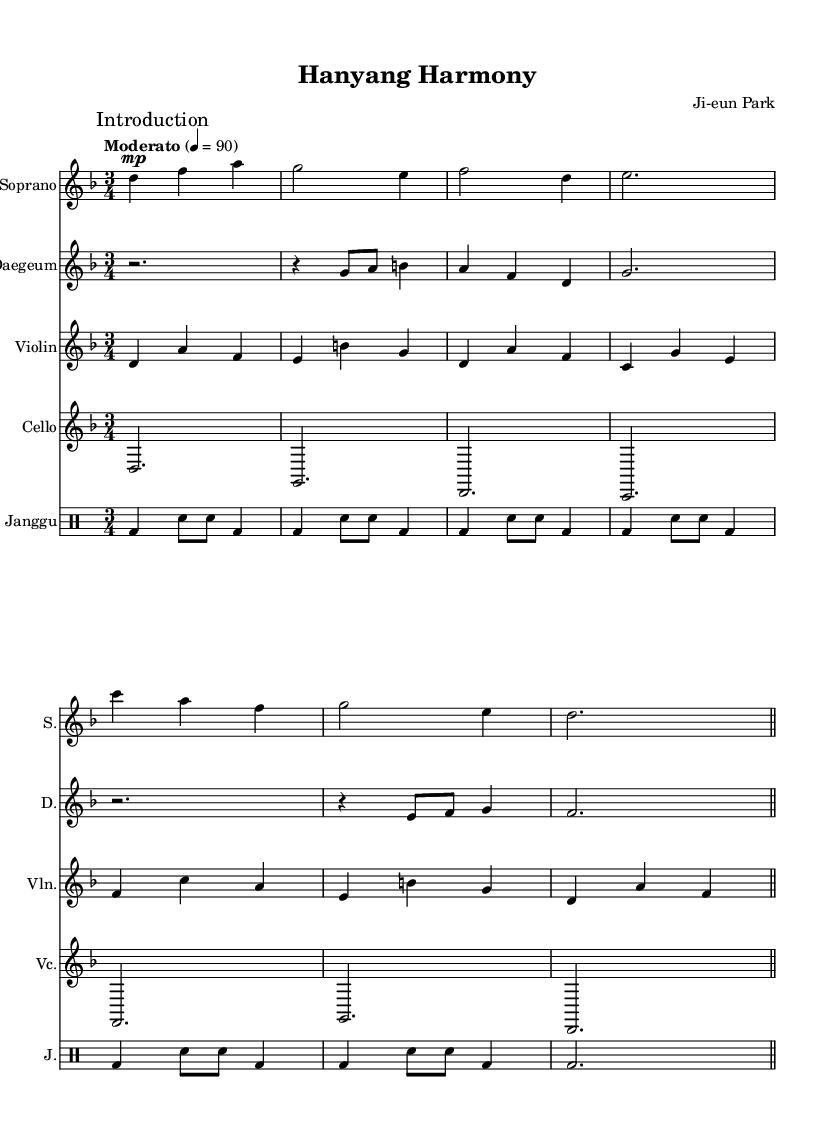What is the key signature of this music? The key signature is D minor, which includes one flat (B flat). We can identify the key signature indicated at the beginning of the staff, which specifies that this piece is in D minor.
Answer: D minor What is the time signature of this music? The time signature is 3/4, which means there are three beats in each measure and the quarter note gets one beat. This is noted in the time signature at the beginning of the score.
Answer: 3/4 What is the tempo marking of this piece? The tempo marking is Moderato, indicated at the beginning of the score with a metronome marking of 90 beats per minute. This informs the performers to play at a moderate speed.
Answer: Moderato Which instrument plays the introduction? The introduction is played by the Soprano, as indicated by the mark in the score and the first section notated under the Soprano staff.
Answer: Soprano How many measures are there in the excerpt? There are a total of 8 measures in the excerpt, as we can count the vertical bar lines that separate the measures across the staves.
Answer: 8 What instrument is primarily associated with traditional Korean music in this composition? The Daegeum is the instrument associated with traditional Korean music in this piece. It is specified in the score and includes traditional melodic lines.
Answer: Daegeum What rhythmic pattern is primarily used in the Janggu part? The rhythmic pattern consists of a series of bass and snare drum hits, alternating as indicated by the notations in the Janggu staff. This rhythmic structure reflects the traditional Korean drumming style.
Answer: Alternating bass and snare 